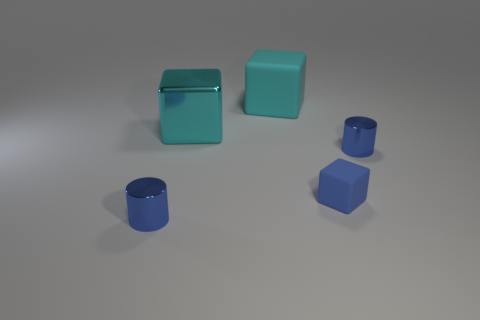Add 3 small matte objects. How many objects exist? 8 Subtract all cubes. How many objects are left? 2 Subtract all big cyan metal spheres. Subtract all cyan cubes. How many objects are left? 3 Add 5 tiny blue shiny cylinders. How many tiny blue shiny cylinders are left? 7 Add 4 big cyan blocks. How many big cyan blocks exist? 6 Subtract 2 blue cylinders. How many objects are left? 3 